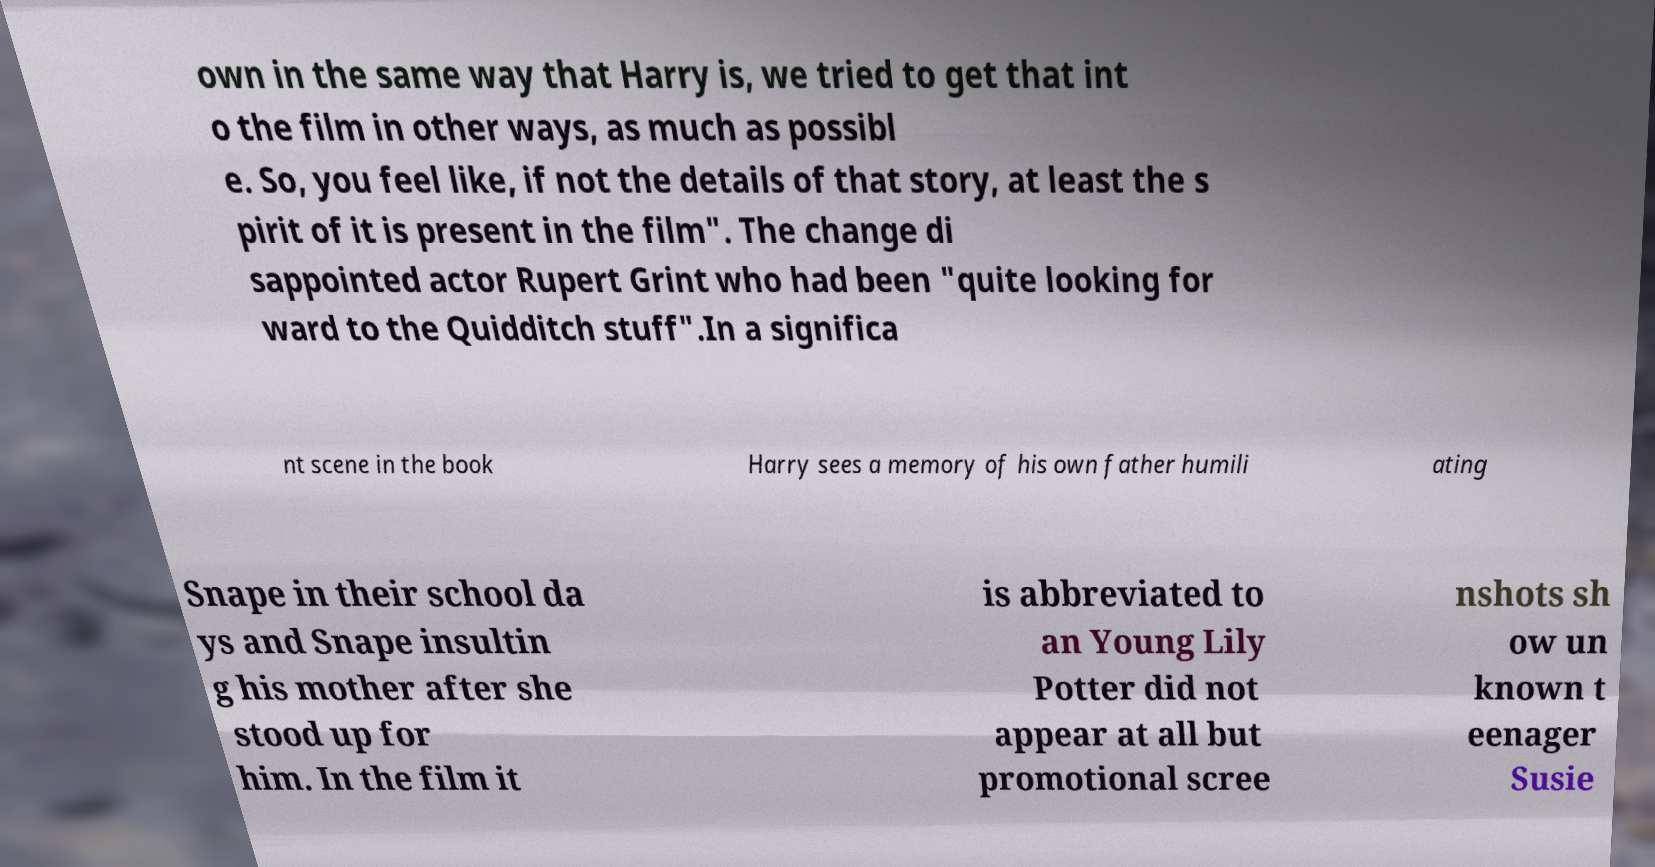For documentation purposes, I need the text within this image transcribed. Could you provide that? own in the same way that Harry is, we tried to get that int o the film in other ways, as much as possibl e. So, you feel like, if not the details of that story, at least the s pirit of it is present in the film". The change di sappointed actor Rupert Grint who had been "quite looking for ward to the Quidditch stuff".In a significa nt scene in the book Harry sees a memory of his own father humili ating Snape in their school da ys and Snape insultin g his mother after she stood up for him. In the film it is abbreviated to an Young Lily Potter did not appear at all but promotional scree nshots sh ow un known t eenager Susie 